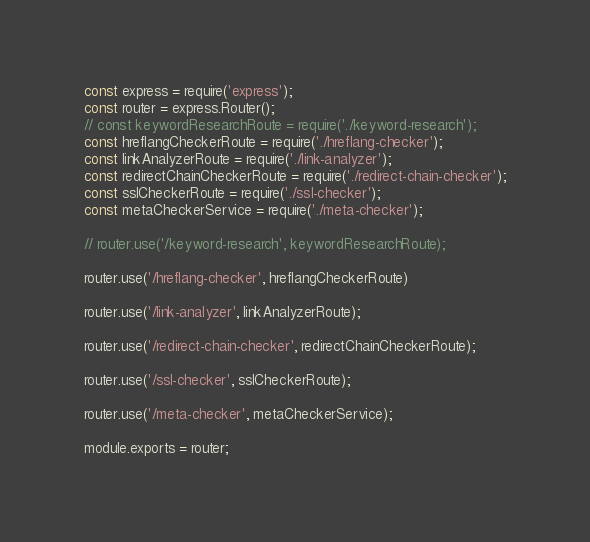<code> <loc_0><loc_0><loc_500><loc_500><_JavaScript_>const express = require('express');
const router = express.Router();
// const keywordResearchRoute = require('./keyword-research');
const hreflangCheckerRoute = require('./hreflang-checker');
const linkAnalyzerRoute = require('./link-analyzer');
const redirectChainCheckerRoute = require('./redirect-chain-checker');
const sslCheckerRoute = require('./ssl-checker');
const metaCheckerService = require('./meta-checker');

// router.use('/keyword-research', keywordResearchRoute);

router.use('/hreflang-checker', hreflangCheckerRoute)

router.use('/link-analyzer', linkAnalyzerRoute);

router.use('/redirect-chain-checker', redirectChainCheckerRoute);

router.use('/ssl-checker', sslCheckerRoute);

router.use('/meta-checker', metaCheckerService);

module.exports = router;
</code> 